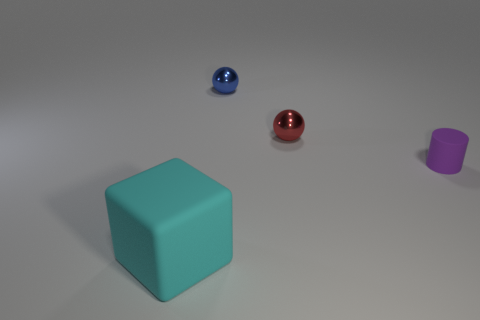What size is the rubber block?
Give a very brief answer. Large. Is there a blue thing that has the same shape as the red thing?
Ensure brevity in your answer.  Yes. What number of things are large blocks or rubber things that are on the left side of the purple object?
Your answer should be very brief. 1. What color is the matte thing that is behind the big rubber cube?
Provide a short and direct response. Purple. Does the thing that is in front of the tiny cylinder have the same size as the matte thing to the right of the big cyan matte object?
Ensure brevity in your answer.  No. Are there any blue spheres of the same size as the cylinder?
Offer a very short reply. Yes. There is a matte thing that is left of the tiny red metallic thing; what number of tiny purple rubber objects are behind it?
Make the answer very short. 1. What is the tiny red object made of?
Your answer should be compact. Metal. How many metal objects are to the right of the big rubber cube?
Your answer should be compact. 2. Do the big rubber object and the cylinder have the same color?
Give a very brief answer. No. 